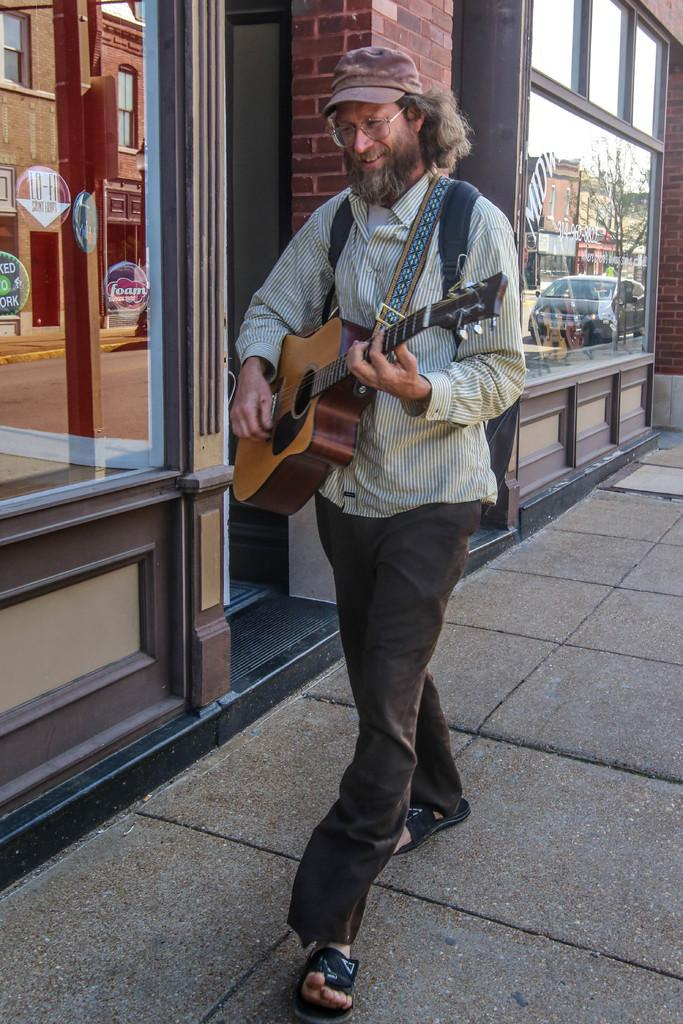What is the main subject of the image? The main subject of the image is a man. What is the man doing in the image? The man is walking and playing a guitar. Can you describe the man's attire? The man is wearing a cap. What can be seen in the background of the image? There is a building in the image, and a car is visible on the glass of the building. What type of crate is the man using to carry his guitar in the image? There is no crate present in the image; the man is carrying his guitar while walking. What time is displayed on the clock in the image? There is no clock present in the image. 